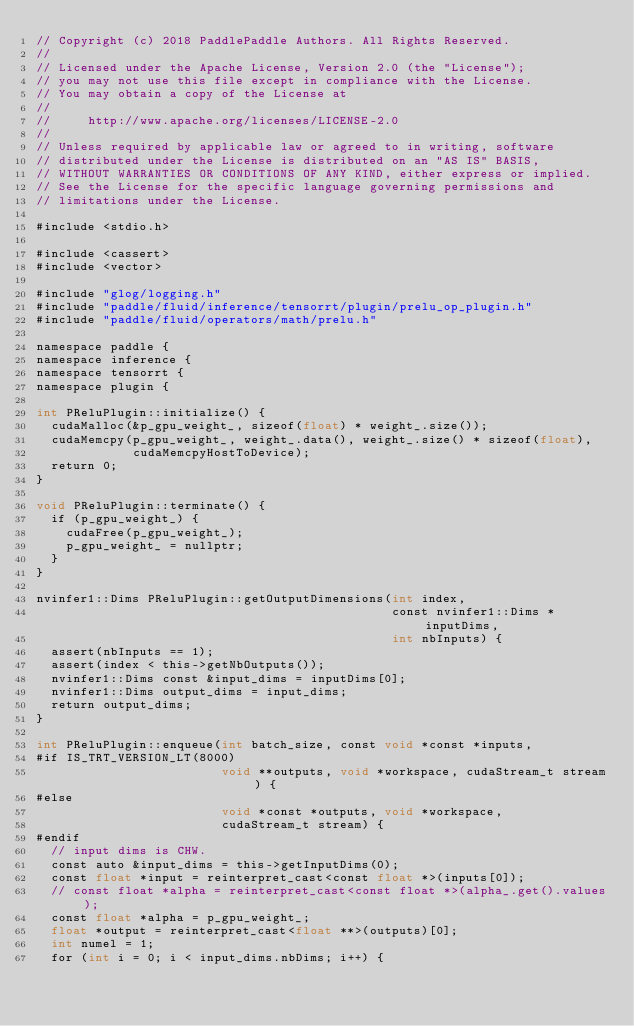<code> <loc_0><loc_0><loc_500><loc_500><_Cuda_>// Copyright (c) 2018 PaddlePaddle Authors. All Rights Reserved.
//
// Licensed under the Apache License, Version 2.0 (the "License");
// you may not use this file except in compliance with the License.
// You may obtain a copy of the License at
//
//     http://www.apache.org/licenses/LICENSE-2.0
//
// Unless required by applicable law or agreed to in writing, software
// distributed under the License is distributed on an "AS IS" BASIS,
// WITHOUT WARRANTIES OR CONDITIONS OF ANY KIND, either express or implied.
// See the License for the specific language governing permissions and
// limitations under the License.

#include <stdio.h>

#include <cassert>
#include <vector>

#include "glog/logging.h"
#include "paddle/fluid/inference/tensorrt/plugin/prelu_op_plugin.h"
#include "paddle/fluid/operators/math/prelu.h"

namespace paddle {
namespace inference {
namespace tensorrt {
namespace plugin {

int PReluPlugin::initialize() {
  cudaMalloc(&p_gpu_weight_, sizeof(float) * weight_.size());
  cudaMemcpy(p_gpu_weight_, weight_.data(), weight_.size() * sizeof(float),
             cudaMemcpyHostToDevice);
  return 0;
}

void PReluPlugin::terminate() {
  if (p_gpu_weight_) {
    cudaFree(p_gpu_weight_);
    p_gpu_weight_ = nullptr;
  }
}

nvinfer1::Dims PReluPlugin::getOutputDimensions(int index,
                                                const nvinfer1::Dims *inputDims,
                                                int nbInputs) {
  assert(nbInputs == 1);
  assert(index < this->getNbOutputs());
  nvinfer1::Dims const &input_dims = inputDims[0];
  nvinfer1::Dims output_dims = input_dims;
  return output_dims;
}

int PReluPlugin::enqueue(int batch_size, const void *const *inputs,
#if IS_TRT_VERSION_LT(8000)
                         void **outputs, void *workspace, cudaStream_t stream) {
#else
                         void *const *outputs, void *workspace,
                         cudaStream_t stream) {
#endif
  // input dims is CHW.
  const auto &input_dims = this->getInputDims(0);
  const float *input = reinterpret_cast<const float *>(inputs[0]);
  // const float *alpha = reinterpret_cast<const float *>(alpha_.get().values);
  const float *alpha = p_gpu_weight_;
  float *output = reinterpret_cast<float **>(outputs)[0];
  int numel = 1;
  for (int i = 0; i < input_dims.nbDims; i++) {</code> 